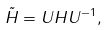<formula> <loc_0><loc_0><loc_500><loc_500>\tilde { H } = U H U ^ { - 1 } ,</formula> 